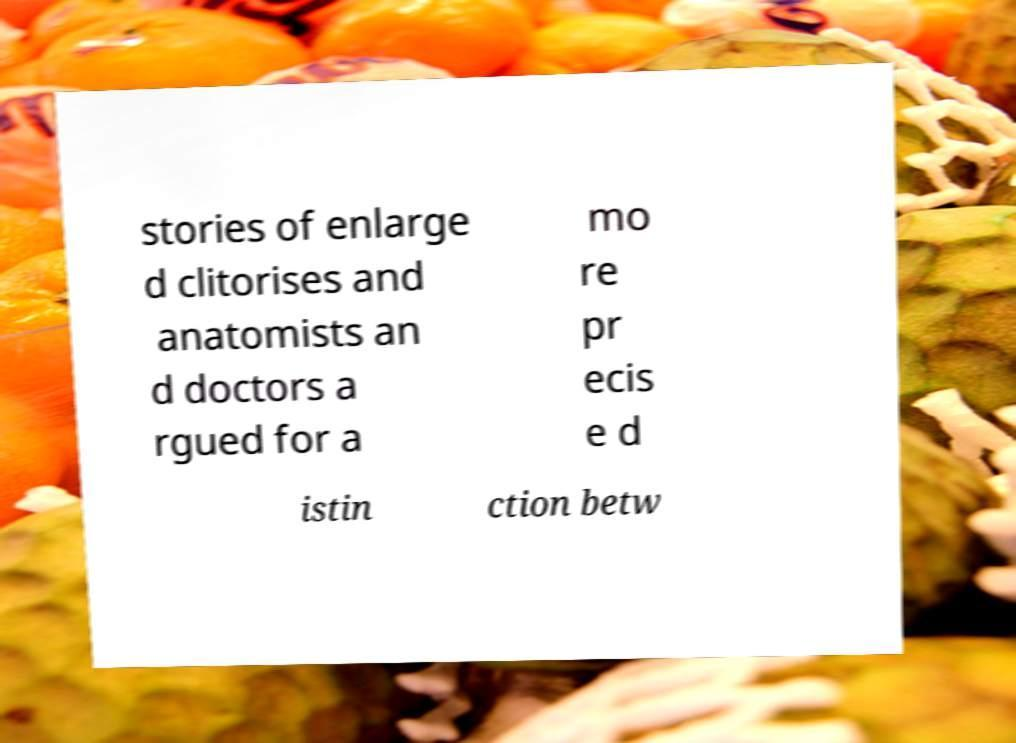What messages or text are displayed in this image? I need them in a readable, typed format. stories of enlarge d clitorises and anatomists an d doctors a rgued for a mo re pr ecis e d istin ction betw 